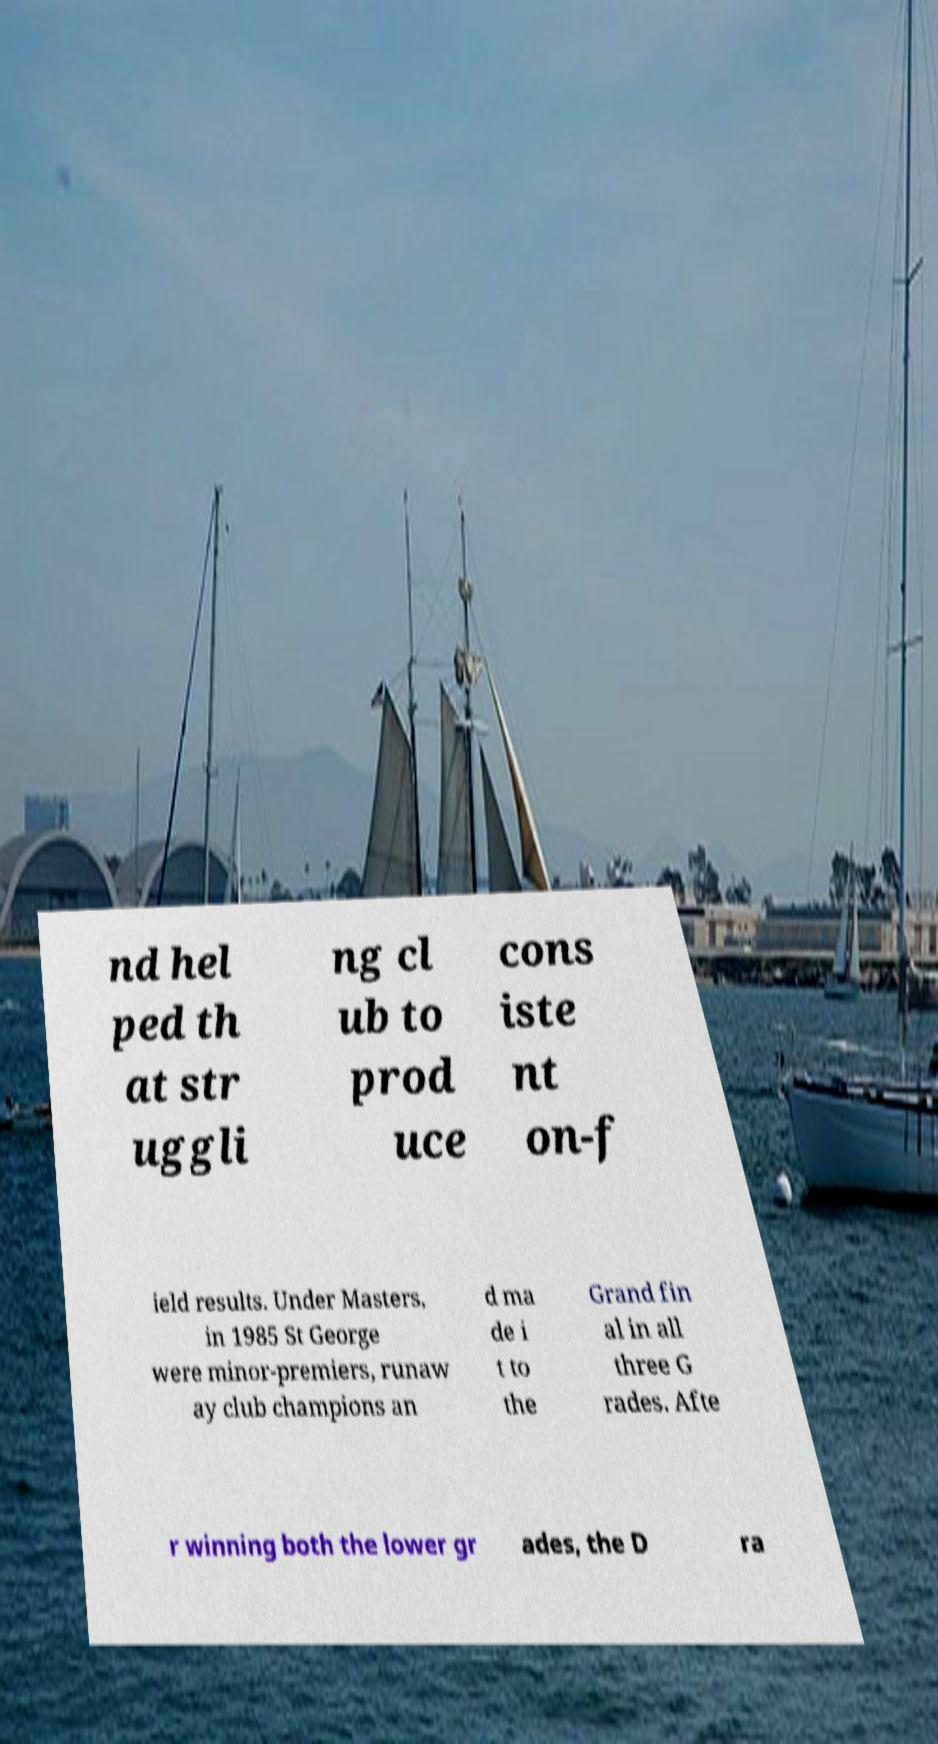I need the written content from this picture converted into text. Can you do that? nd hel ped th at str uggli ng cl ub to prod uce cons iste nt on-f ield results. Under Masters, in 1985 St George were minor-premiers, runaw ay club champions an d ma de i t to the Grand fin al in all three G rades. Afte r winning both the lower gr ades, the D ra 